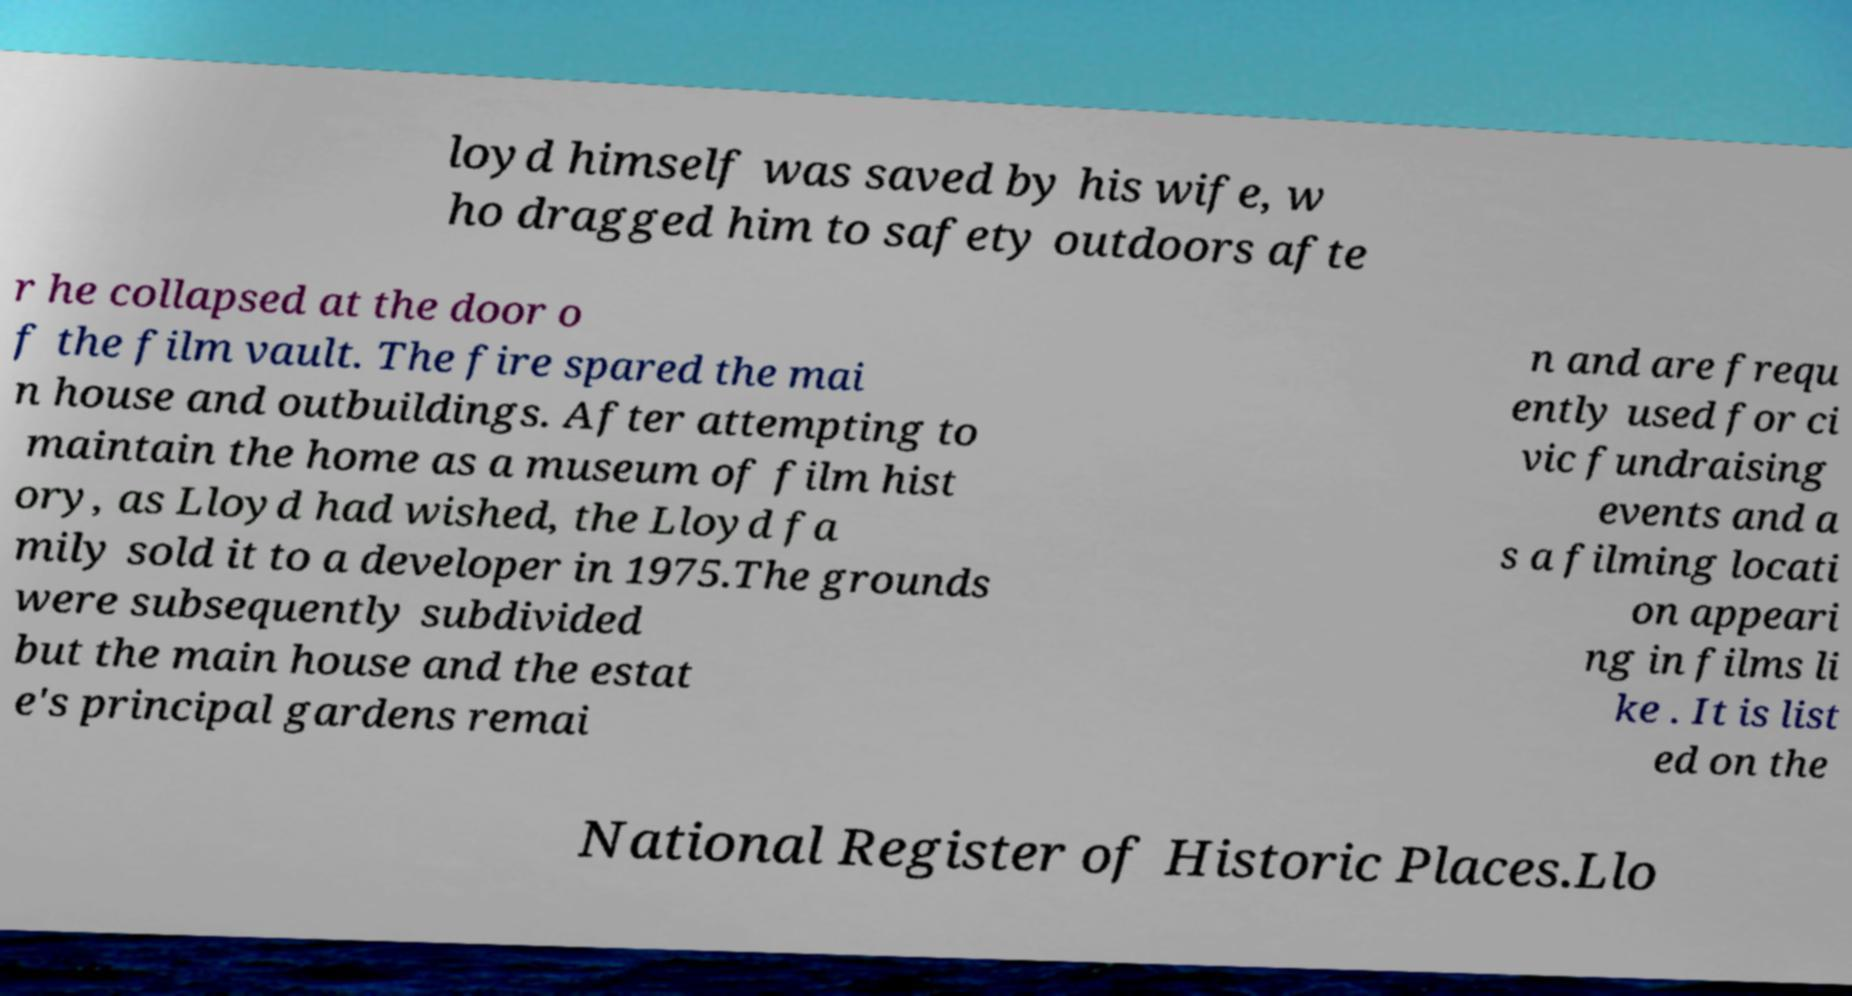Please read and relay the text visible in this image. What does it say? loyd himself was saved by his wife, w ho dragged him to safety outdoors afte r he collapsed at the door o f the film vault. The fire spared the mai n house and outbuildings. After attempting to maintain the home as a museum of film hist ory, as Lloyd had wished, the Lloyd fa mily sold it to a developer in 1975.The grounds were subsequently subdivided but the main house and the estat e's principal gardens remai n and are frequ ently used for ci vic fundraising events and a s a filming locati on appeari ng in films li ke . It is list ed on the National Register of Historic Places.Llo 